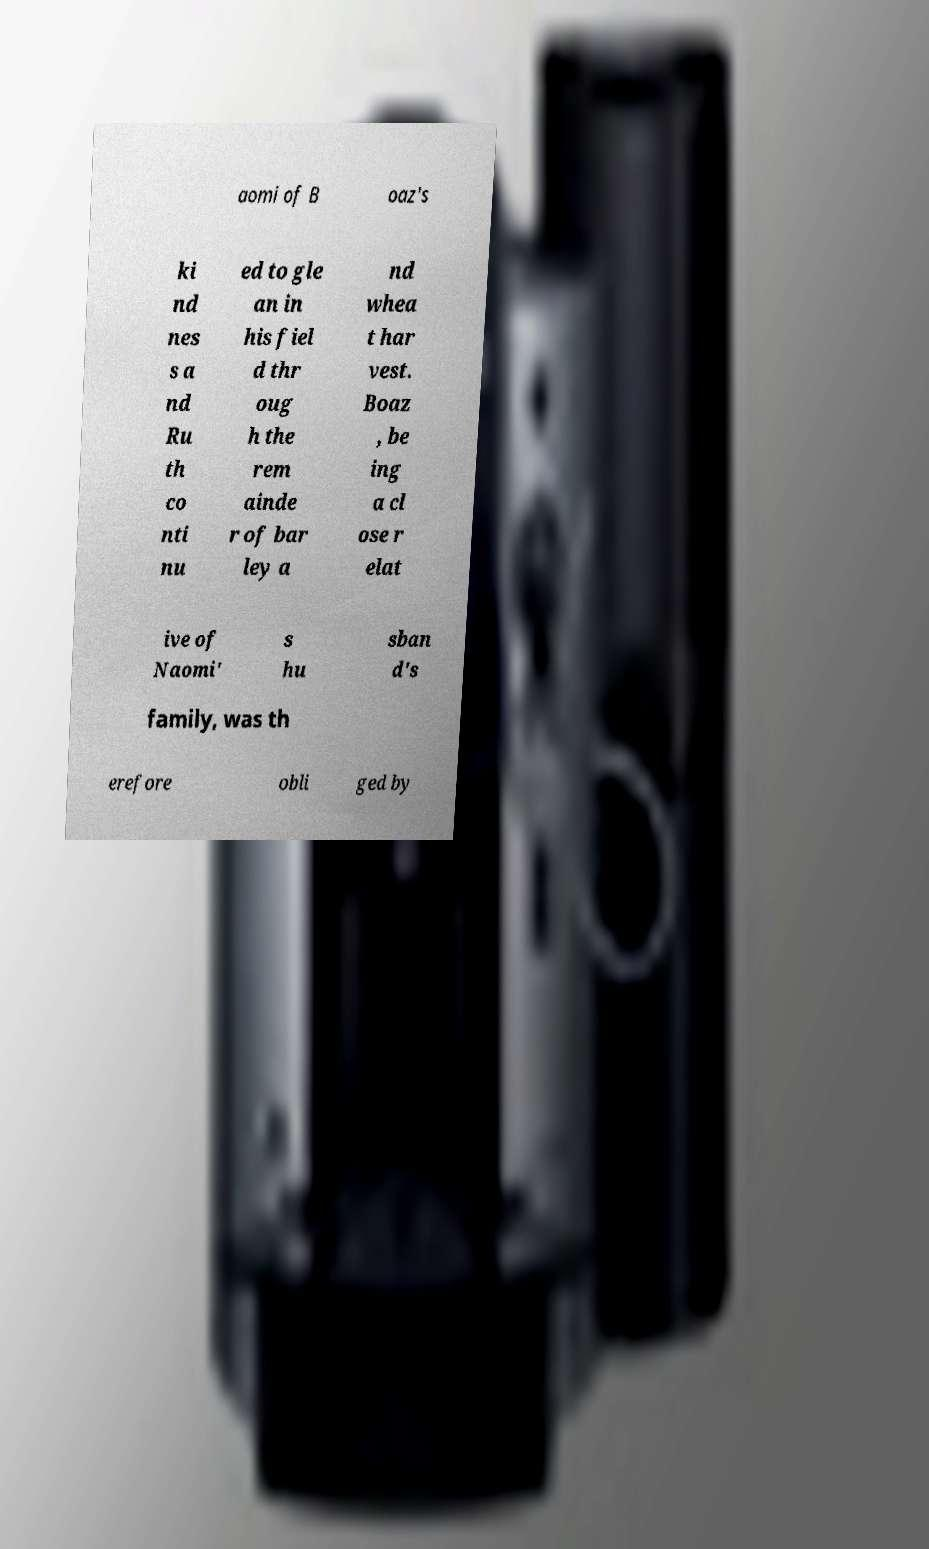There's text embedded in this image that I need extracted. Can you transcribe it verbatim? aomi of B oaz's ki nd nes s a nd Ru th co nti nu ed to gle an in his fiel d thr oug h the rem ainde r of bar ley a nd whea t har vest. Boaz , be ing a cl ose r elat ive of Naomi' s hu sban d's family, was th erefore obli ged by 